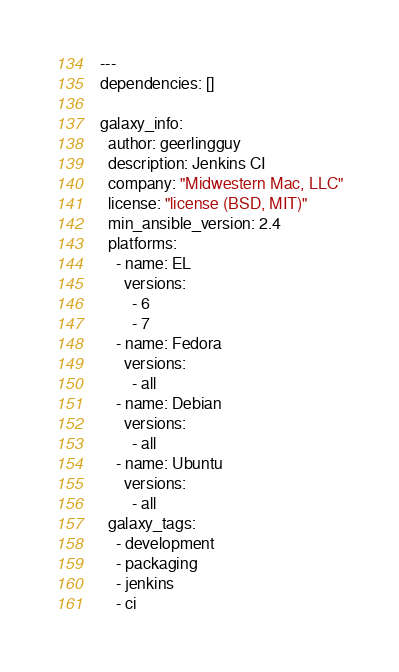<code> <loc_0><loc_0><loc_500><loc_500><_YAML_>---
dependencies: []

galaxy_info:
  author: geerlingguy
  description: Jenkins CI
  company: "Midwestern Mac, LLC"
  license: "license (BSD, MIT)"
  min_ansible_version: 2.4
  platforms:
    - name: EL
      versions:
        - 6
        - 7
    - name: Fedora
      versions:
        - all
    - name: Debian
      versions:
        - all
    - name: Ubuntu
      versions:
        - all
  galaxy_tags:
    - development
    - packaging
    - jenkins
    - ci
</code> 